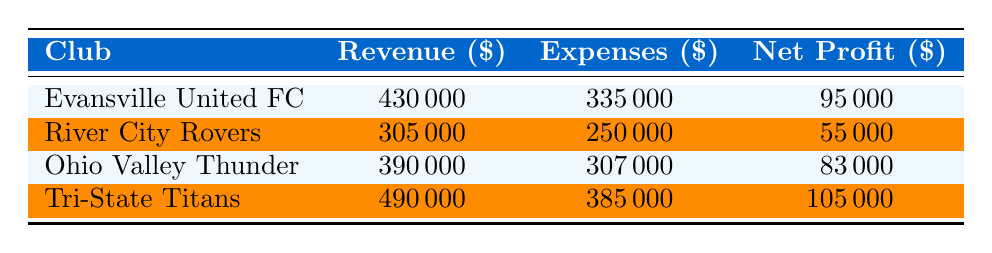What is the total revenue for Tri-State Titans? Referring to the table, the revenue for Tri-State Titans is listed as 490000.
Answer: 490000 What is the net profit for River City Rovers? As per the table, the net profit for River City Rovers is shown as 55000.
Answer: 55000 Which club has the highest revenue? By comparing the revenue across clubs, Tri-State Titans has the highest revenue at 490000, while the others are lower.
Answer: Tri-State Titans What is the average net profit of all clubs? To find the average, sum the net profits: (95000 + 55000 + 83000 + 105000) = 300000. Then divide by 4 (number of clubs): 300000 / 4 = 75000.
Answer: 75000 Is the total revenue for Ohio Valley Thunder greater than that of River City Rovers? Ohio Valley Thunder has a revenue of 390000, while River City Rovers has a revenue of 305000. Since 390000 is greater than 305000, the statement is true.
Answer: Yes What is the difference in net profit between Tri-State Titans and Evansville United FC? Tri-State Titans has a net profit of 105000 and Evansville United FC has a net profit of 95000. The difference is 105000 - 95000 = 10000.
Answer: 10000 How does the cost of salaries for each club compare? The salaries for each club are as follows: Evansville United FC - 160000, River City Rovers - 120000, Ohio Valley Thunder - 150000, Tri-State Titans - 180000. The highest is Tri-State Titans and the lowest is River City Rovers.
Answer: Tri-State Titans has the highest, River City Rovers has the lowest Is the total expenses for Ohio Valley Thunder higher than the average expenses of all clubs? The total expenses for Ohio Valley Thunder is 307000, and the average expenses for all clubs can be calculated as follows: (335000 + 250000 + 307000 + 385000) = 1275000; then divided by 4 gives 318750. Since 307000 is less than 318750, the answer is false.
Answer: No 